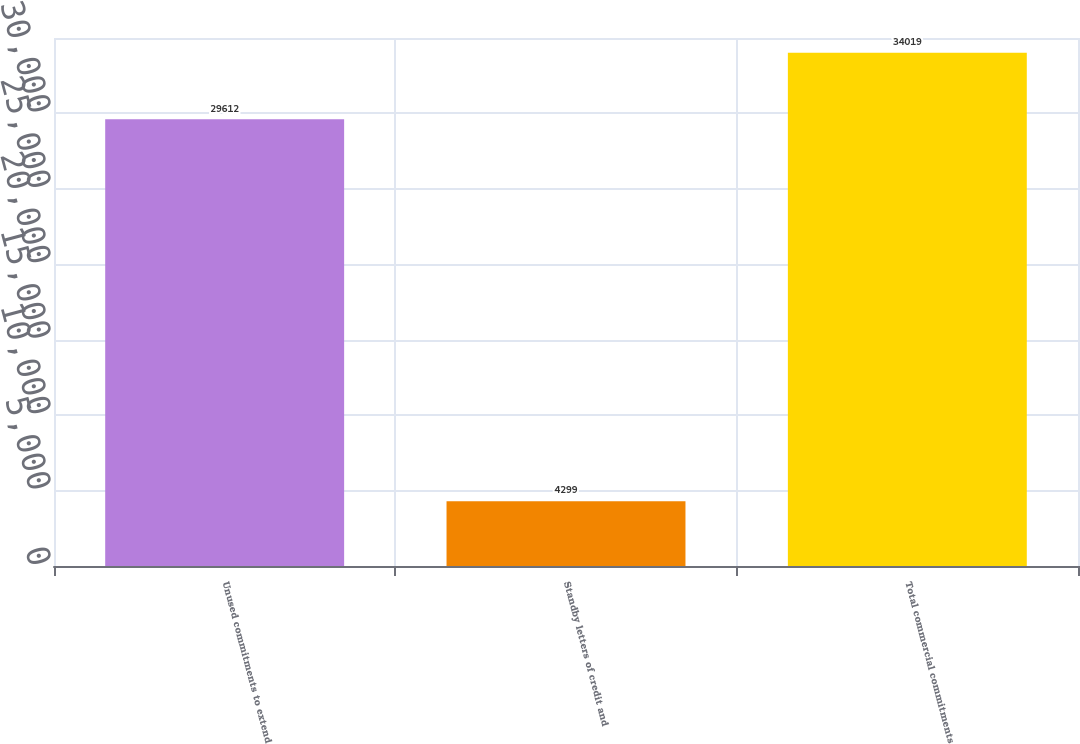Convert chart. <chart><loc_0><loc_0><loc_500><loc_500><bar_chart><fcel>Unused commitments to extend<fcel>Standby letters of credit and<fcel>Total commercial commitments<nl><fcel>29612<fcel>4299<fcel>34019<nl></chart> 